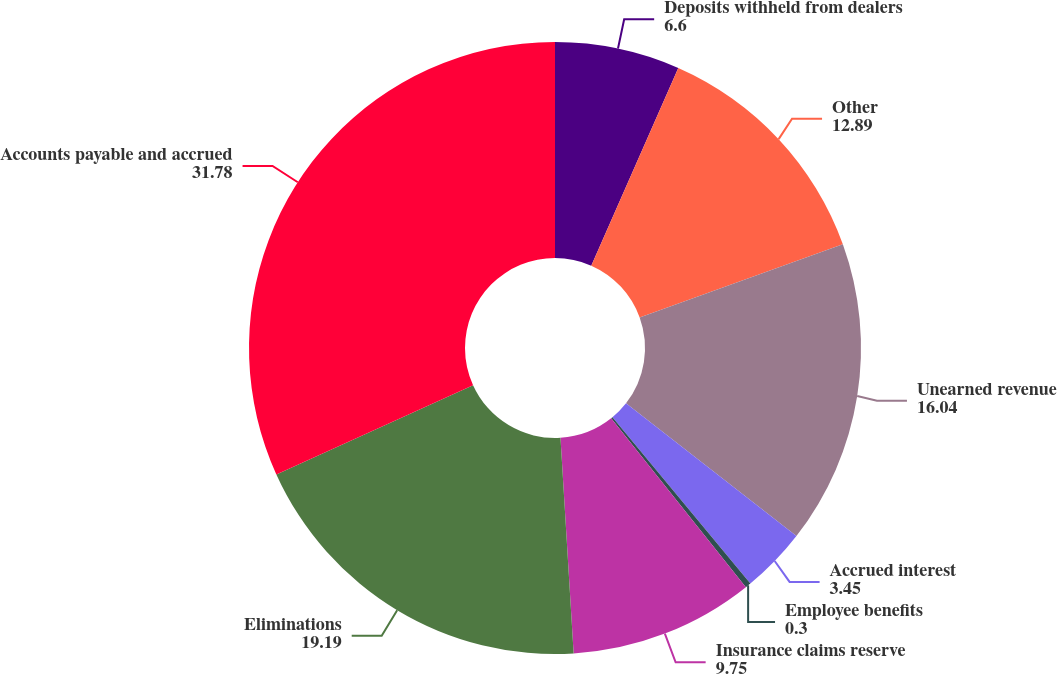<chart> <loc_0><loc_0><loc_500><loc_500><pie_chart><fcel>Deposits withheld from dealers<fcel>Other<fcel>Unearned revenue<fcel>Accrued interest<fcel>Employee benefits<fcel>Insurance claims reserve<fcel>Eliminations<fcel>Accounts payable and accrued<nl><fcel>6.6%<fcel>12.89%<fcel>16.04%<fcel>3.45%<fcel>0.3%<fcel>9.75%<fcel>19.19%<fcel>31.78%<nl></chart> 